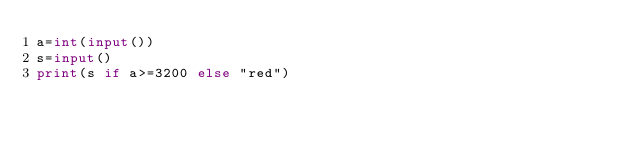<code> <loc_0><loc_0><loc_500><loc_500><_Python_>a=int(input())
s=input()
print(s if a>=3200 else "red")</code> 